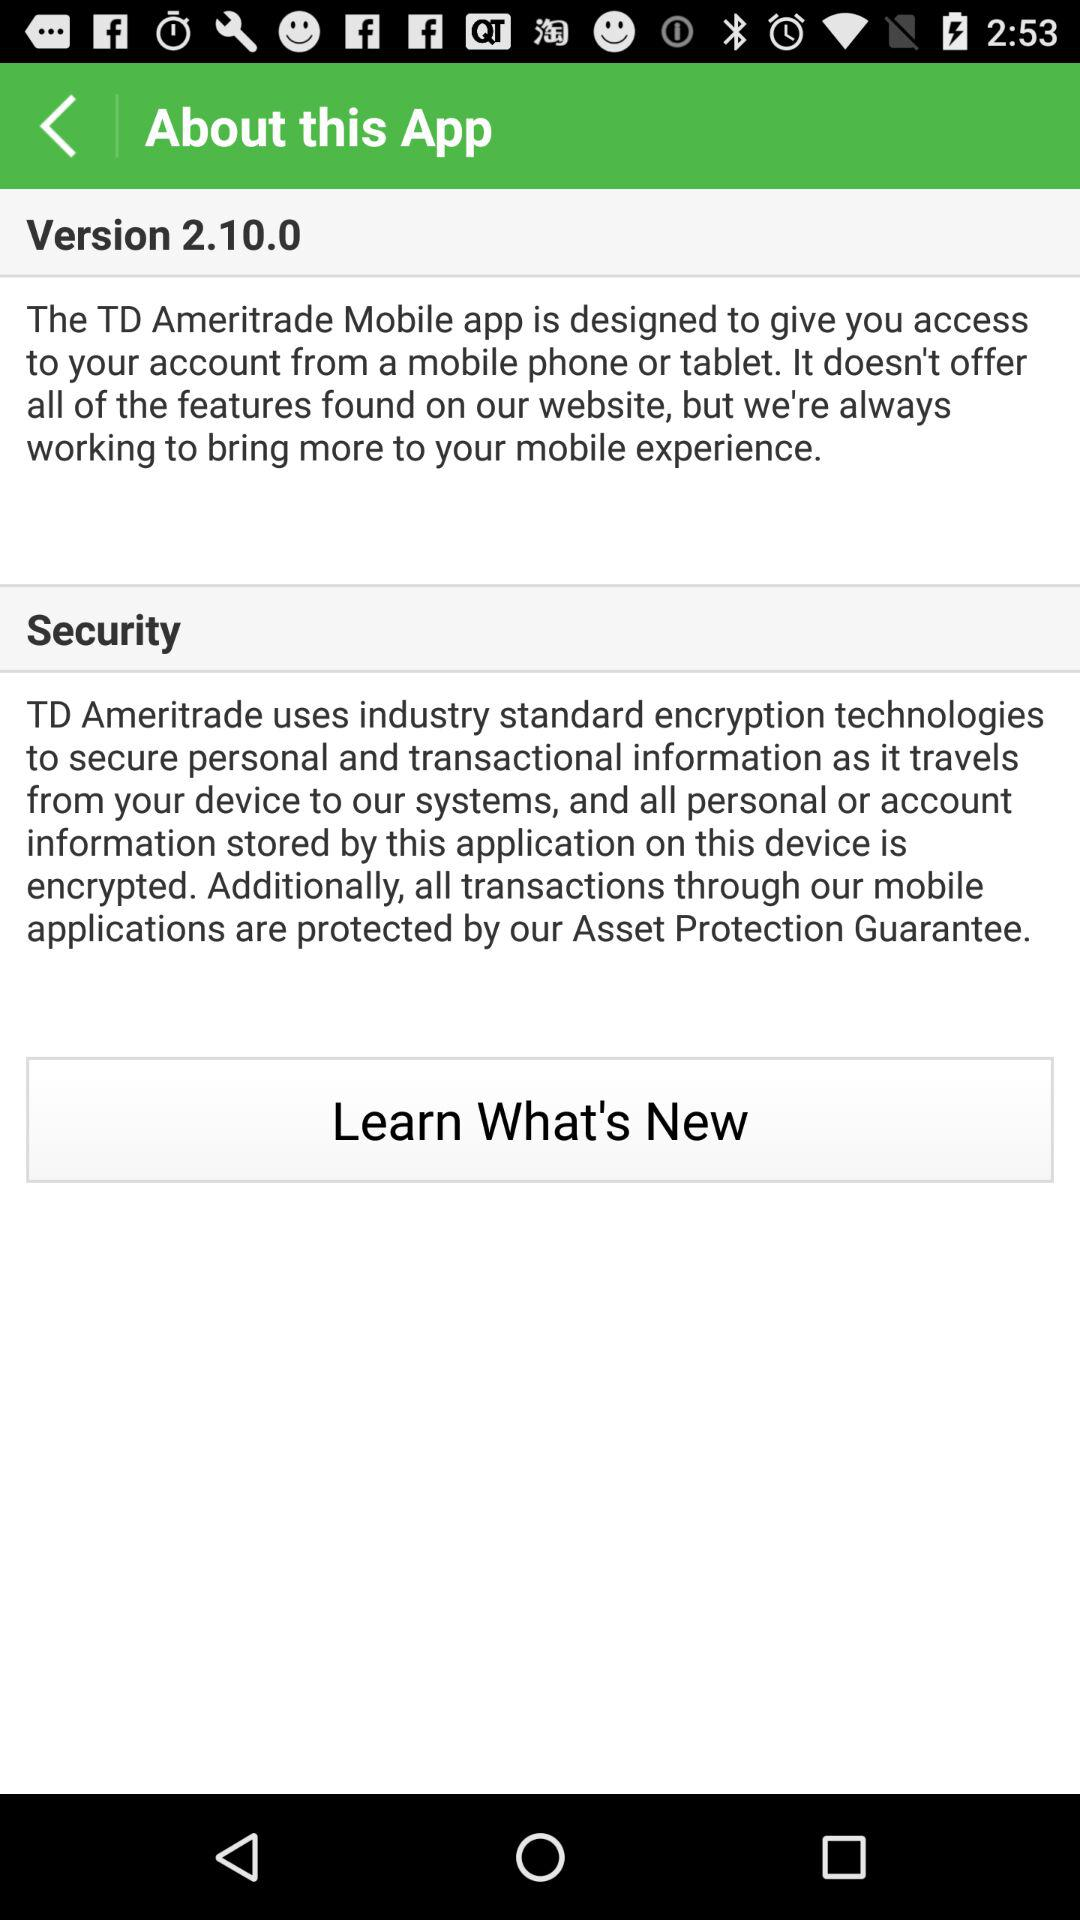What is the version of the "TD Ameritrade Mobile" app? The version of the "TD Ameritrade Mobile" app is 2.10.0. 